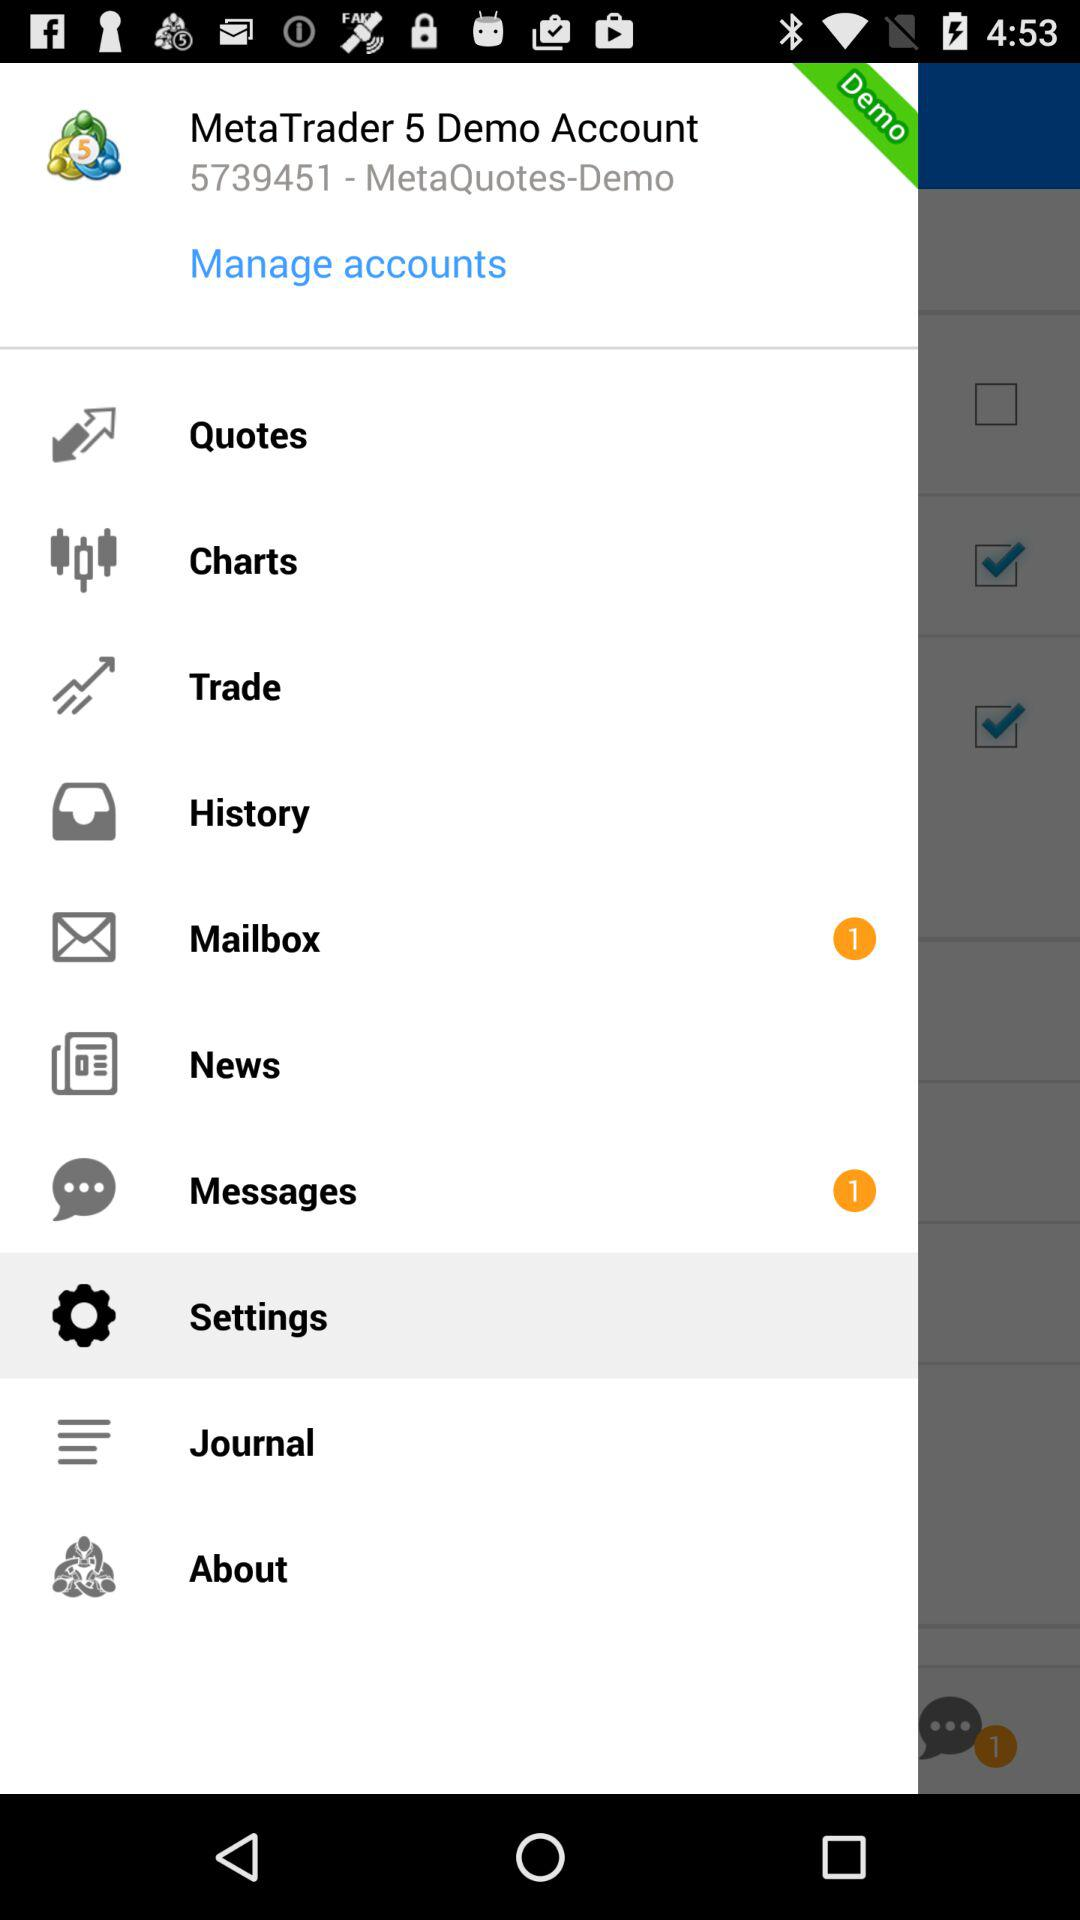How many new emails are there in the mailbox? There is 1 new email. 